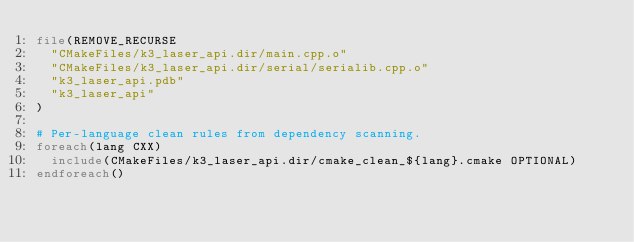Convert code to text. <code><loc_0><loc_0><loc_500><loc_500><_CMake_>file(REMOVE_RECURSE
  "CMakeFiles/k3_laser_api.dir/main.cpp.o"
  "CMakeFiles/k3_laser_api.dir/serial/serialib.cpp.o"
  "k3_laser_api.pdb"
  "k3_laser_api"
)

# Per-language clean rules from dependency scanning.
foreach(lang CXX)
  include(CMakeFiles/k3_laser_api.dir/cmake_clean_${lang}.cmake OPTIONAL)
endforeach()
</code> 